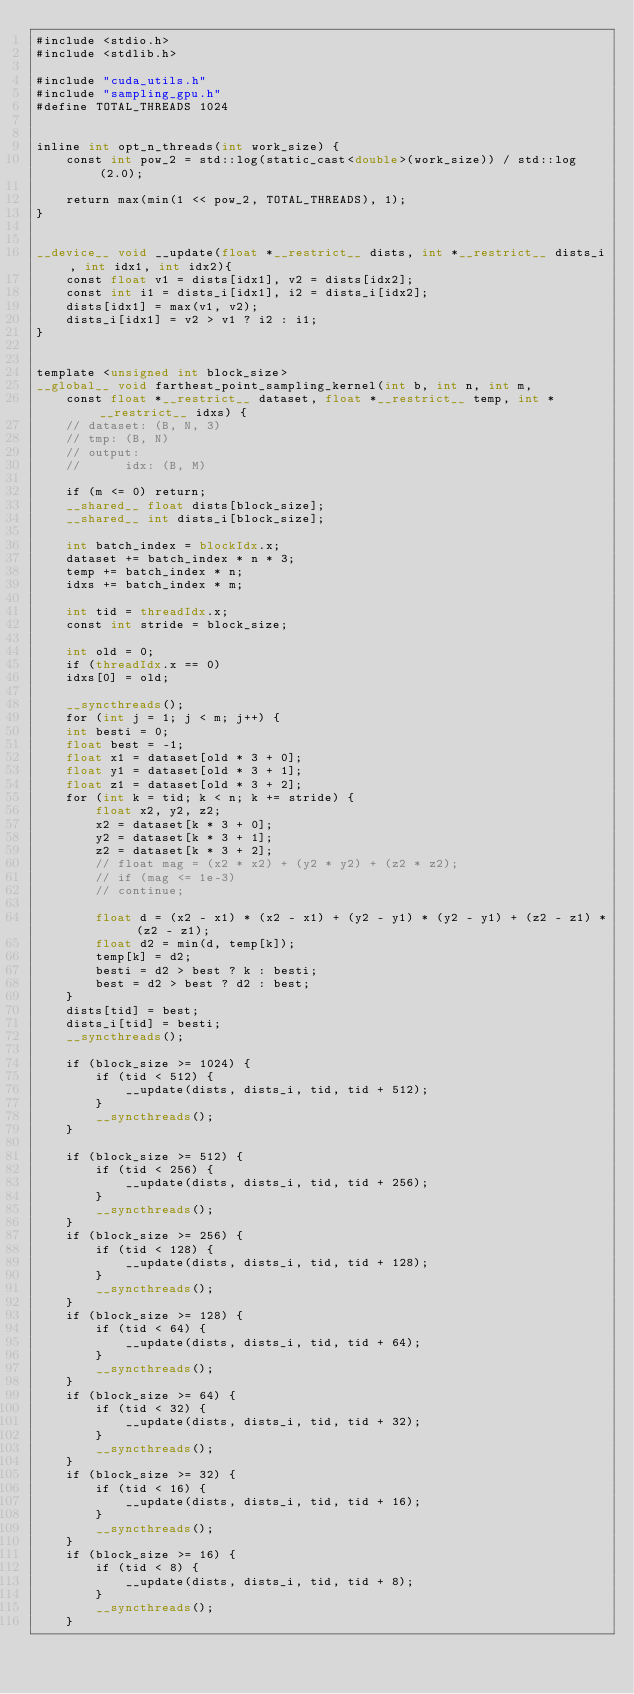Convert code to text. <code><loc_0><loc_0><loc_500><loc_500><_Cuda_>#include <stdio.h>
#include <stdlib.h>

#include "cuda_utils.h"
#include "sampling_gpu.h"
#define TOTAL_THREADS 1024


inline int opt_n_threads(int work_size) {
    const int pow_2 = std::log(static_cast<double>(work_size)) / std::log(2.0);

    return max(min(1 << pow_2, TOTAL_THREADS), 1);
}


__device__ void __update(float *__restrict__ dists, int *__restrict__ dists_i, int idx1, int idx2){
    const float v1 = dists[idx1], v2 = dists[idx2];
    const int i1 = dists_i[idx1], i2 = dists_i[idx2];
    dists[idx1] = max(v1, v2);
    dists_i[idx1] = v2 > v1 ? i2 : i1;
}


template <unsigned int block_size>
__global__ void farthest_point_sampling_kernel(int b, int n, int m,
    const float *__restrict__ dataset, float *__restrict__ temp, int *__restrict__ idxs) {
    // dataset: (B, N, 3)
    // tmp: (B, N)
    // output:
    //      idx: (B, M)

    if (m <= 0) return;
    __shared__ float dists[block_size];
    __shared__ int dists_i[block_size];

    int batch_index = blockIdx.x;
    dataset += batch_index * n * 3;
    temp += batch_index * n;
    idxs += batch_index * m;

    int tid = threadIdx.x;
    const int stride = block_size;

    int old = 0;
    if (threadIdx.x == 0)
    idxs[0] = old;

    __syncthreads();
    for (int j = 1; j < m; j++) {
    int besti = 0;
    float best = -1;
    float x1 = dataset[old * 3 + 0];
    float y1 = dataset[old * 3 + 1];
    float z1 = dataset[old * 3 + 2];
    for (int k = tid; k < n; k += stride) {
        float x2, y2, z2;
        x2 = dataset[k * 3 + 0];
        y2 = dataset[k * 3 + 1];
        z2 = dataset[k * 3 + 2];
        // float mag = (x2 * x2) + (y2 * y2) + (z2 * z2);
        // if (mag <= 1e-3)
        // continue;

        float d = (x2 - x1) * (x2 - x1) + (y2 - y1) * (y2 - y1) + (z2 - z1) * (z2 - z1);
        float d2 = min(d, temp[k]);
        temp[k] = d2;
        besti = d2 > best ? k : besti;
        best = d2 > best ? d2 : best;
    }
    dists[tid] = best;
    dists_i[tid] = besti;
    __syncthreads();

    if (block_size >= 1024) {
        if (tid < 512) {
            __update(dists, dists_i, tid, tid + 512);
        }
        __syncthreads();
    }

    if (block_size >= 512) {
        if (tid < 256) {
            __update(dists, dists_i, tid, tid + 256);
        }
        __syncthreads();
    }
    if (block_size >= 256) {
        if (tid < 128) {
            __update(dists, dists_i, tid, tid + 128);
        }
        __syncthreads();
    }
    if (block_size >= 128) {
        if (tid < 64) {
            __update(dists, dists_i, tid, tid + 64);
        }
        __syncthreads();
    }
    if (block_size >= 64) {
        if (tid < 32) {
            __update(dists, dists_i, tid, tid + 32);
        }
        __syncthreads();
    }
    if (block_size >= 32) {
        if (tid < 16) {
            __update(dists, dists_i, tid, tid + 16);
        }
        __syncthreads();
    }
    if (block_size >= 16) {
        if (tid < 8) {
            __update(dists, dists_i, tid, tid + 8);
        }
        __syncthreads();
    }</code> 